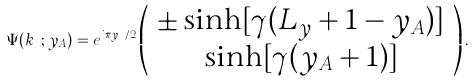Convert formula to latex. <formula><loc_0><loc_0><loc_500><loc_500>\Psi ( k _ { x } ; y _ { A } ) = e ^ { i \pi y _ { A } / 2 } \left ( \begin{array} { c } \pm \sinh [ \gamma ( L _ { y } + 1 - y _ { A } ) ] \\ \sinh [ \gamma ( y _ { A } + 1 ) ] \end{array} \right ) .</formula> 